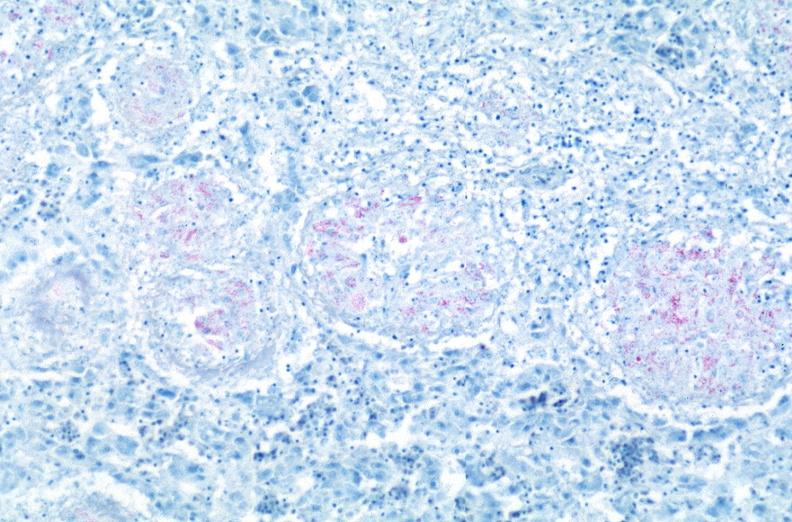does yo show lung, mycobacterium tuberculosis, acid fast?
Answer the question using a single word or phrase. No 